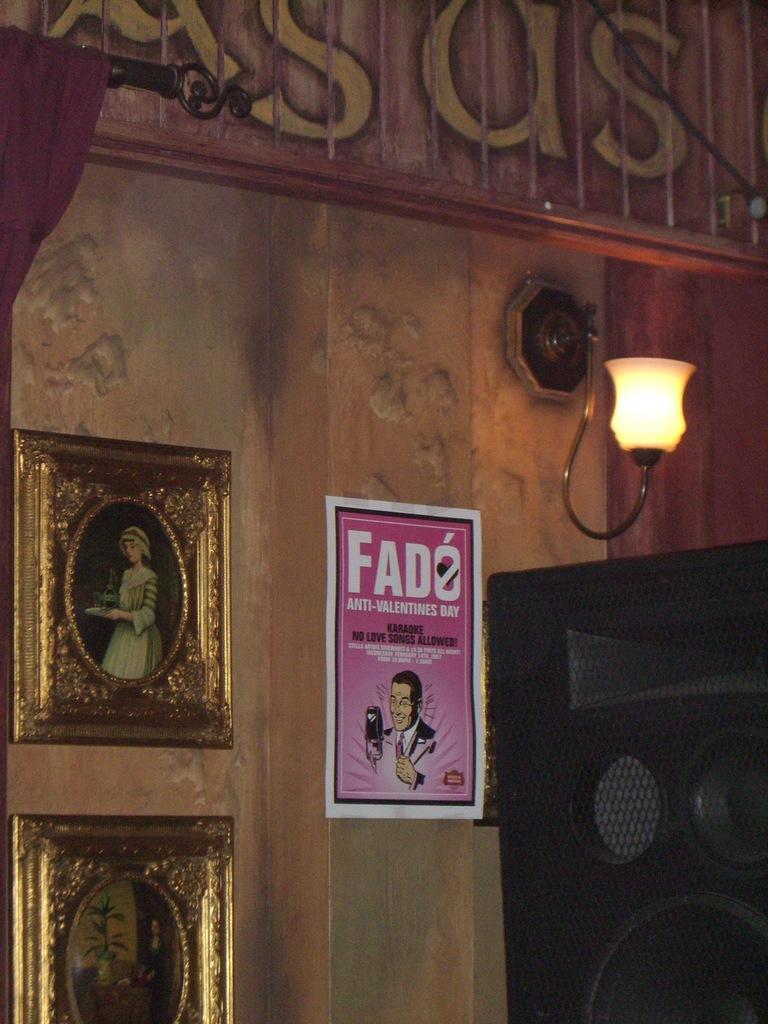Describe this image in one or two sentences. In the center of this picture we can see a poster attached to the wall and we can see the text and picture of a person on the poster. On the right corner there is a black color object seems to be the speaker and we can see a wall mounted lamp. At the top we can see the text on the wall and we can see a curtain, metal rod and picture frames hanging on the wall. 